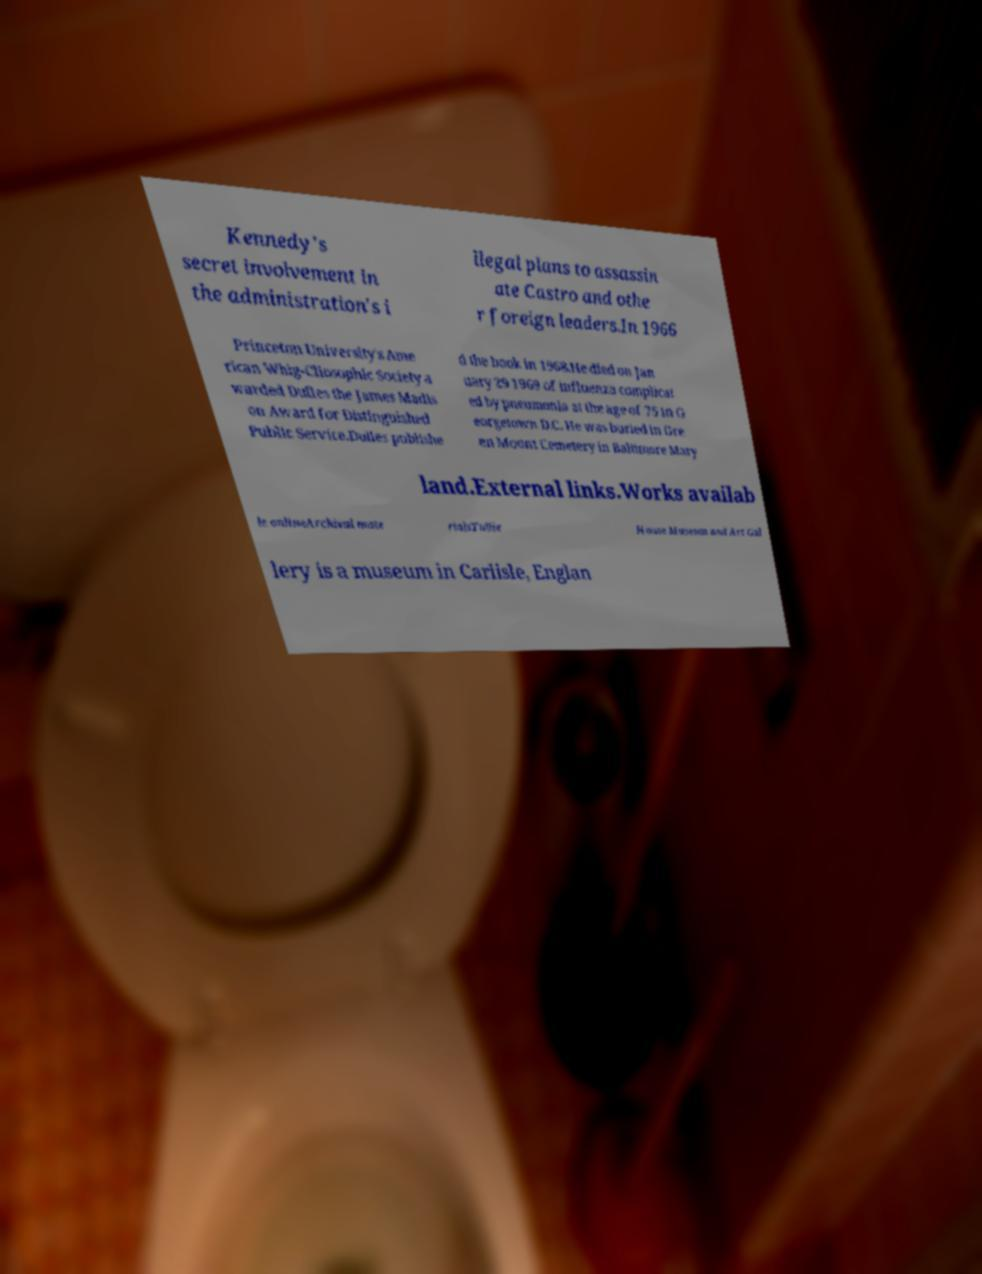Could you assist in decoding the text presented in this image and type it out clearly? Kennedy's secret involvement in the administration's i llegal plans to assassin ate Castro and othe r foreign leaders.In 1966 Princeton University's Ame rican Whig-Cliosophic Society a warded Dulles the James Madis on Award for Distinguished Public Service.Dulles publishe d the book in 1968.He died on Jan uary 29 1969 of influenza complicat ed by pneumonia at the age of 75 in G eorgetown D.C. He was buried in Gre en Mount Cemetery in Baltimore Mary land.External links.Works availab le onlineArchival mate rialsTullie House Museum and Art Gal lery is a museum in Carlisle, Englan 